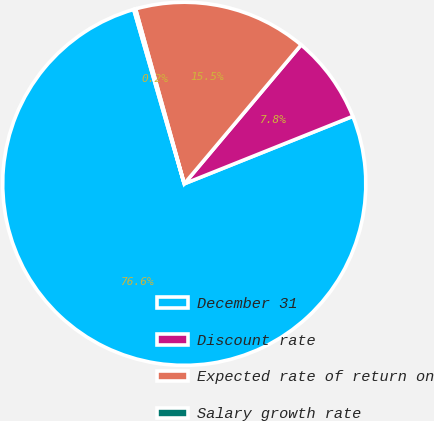Convert chart. <chart><loc_0><loc_0><loc_500><loc_500><pie_chart><fcel>December 31<fcel>Discount rate<fcel>Expected rate of return on<fcel>Salary growth rate<nl><fcel>76.57%<fcel>7.81%<fcel>15.45%<fcel>0.17%<nl></chart> 